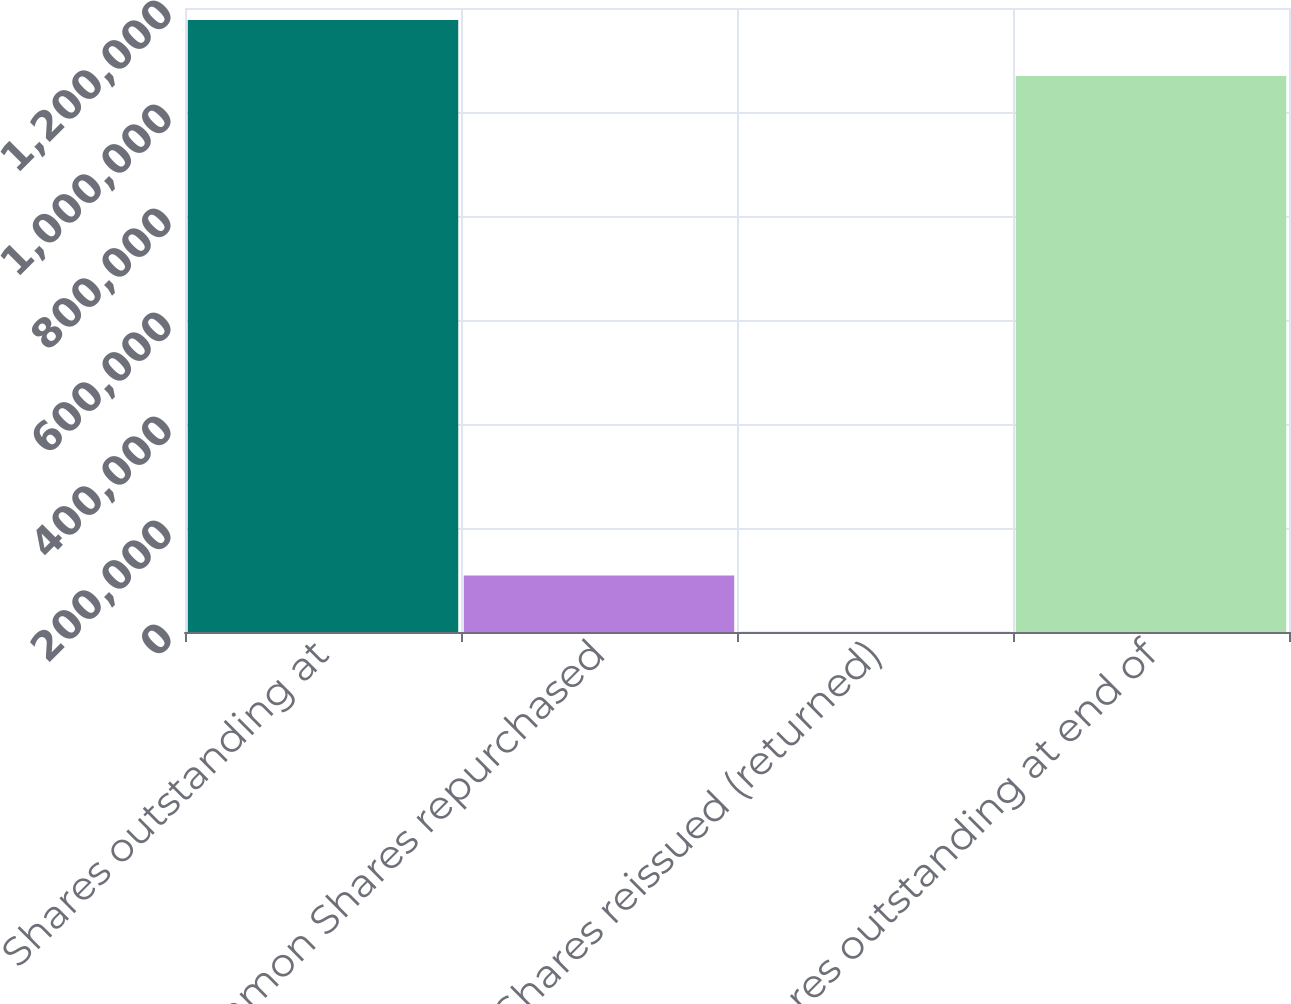<chart> <loc_0><loc_0><loc_500><loc_500><bar_chart><fcel>Shares outstanding at<fcel>Common Shares repurchased<fcel>Shares reissued (returned)<fcel>Shares outstanding at end of<nl><fcel>1.17692e+06<fcel>108500<fcel>662<fcel>1.06908e+06<nl></chart> 